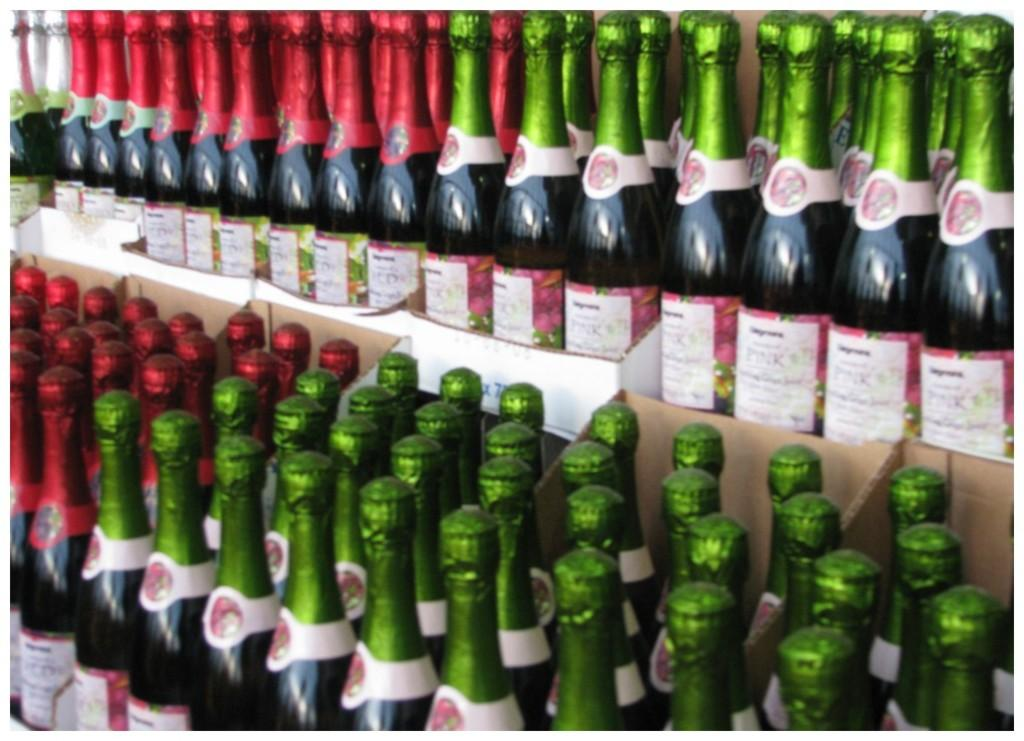Provide a one-sentence caption for the provided image. Several types of champagne with green and red foil, the one with green being Pink type champagne. 